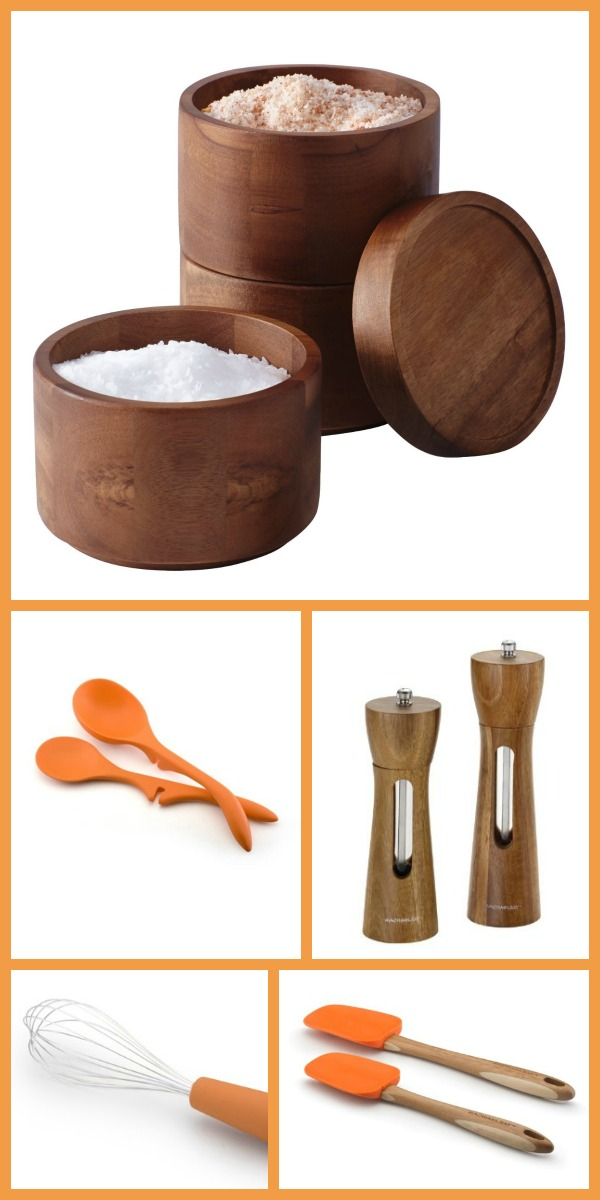Can the silicone whisk be used directly on hot cookware without causing damage? Yes, the silicone whisk shown in the image is designed to be heat-resistant and can be safely used directly on hot cookware without causing any damage. Silicone utensils are gentle on non-stick surfaces, making them perfect for cooking and baking. 